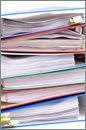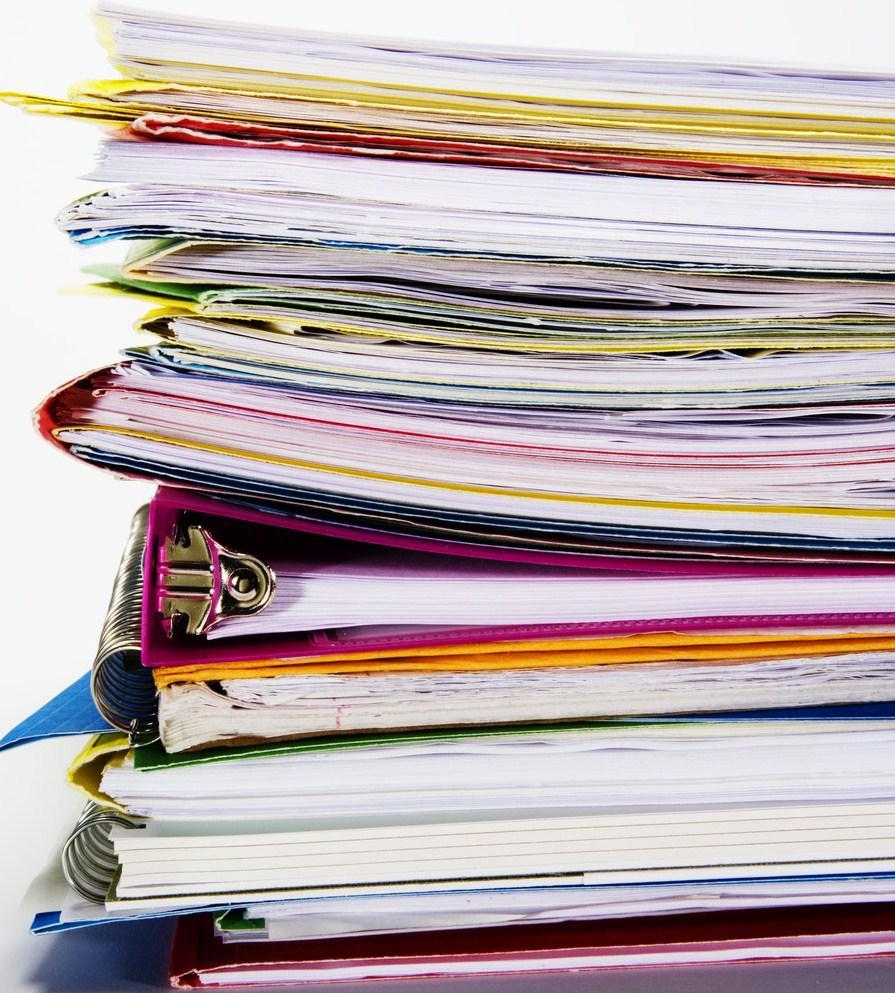The first image is the image on the left, the second image is the image on the right. Analyze the images presented: Is the assertion "There is a person behind a stack of binders." valid? Answer yes or no. No. The first image is the image on the left, the second image is the image on the right. For the images shown, is this caption "The right image contains a stack of binders with a person sitting behind it." true? Answer yes or no. No. 